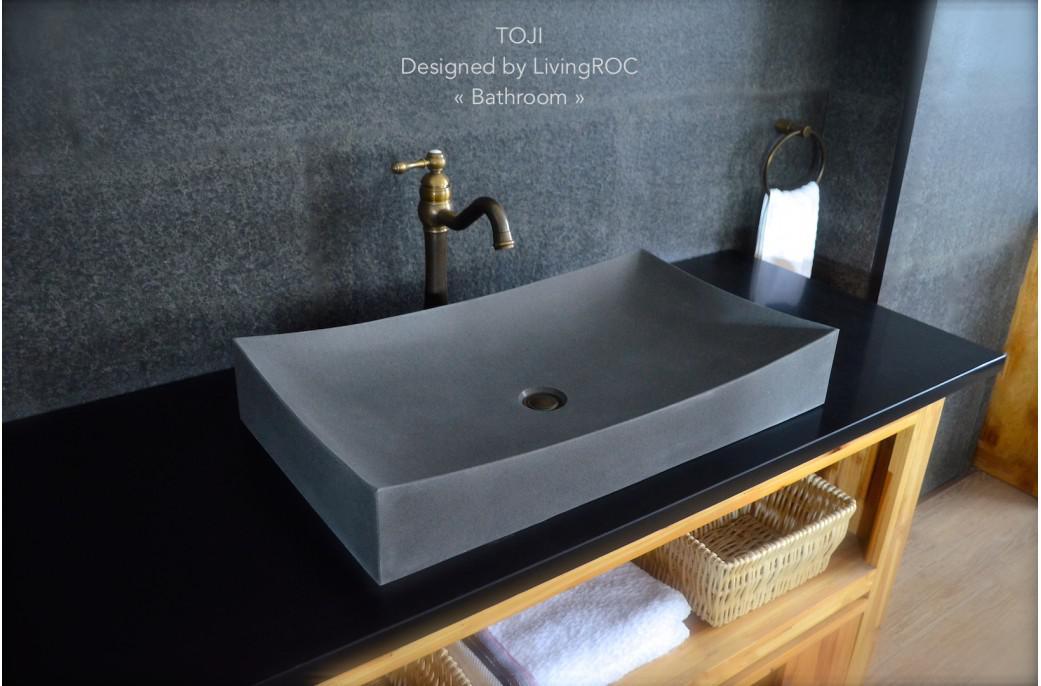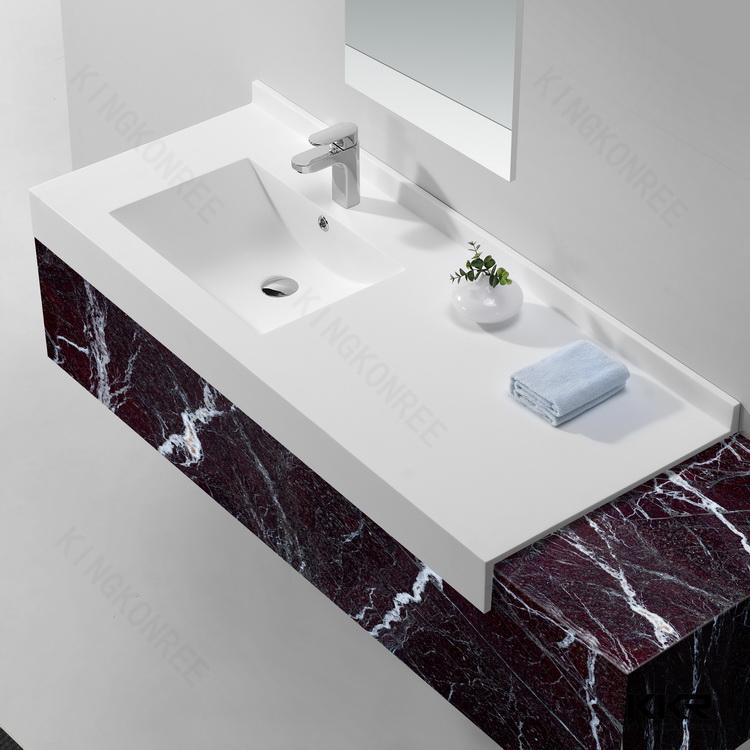The first image is the image on the left, the second image is the image on the right. For the images displayed, is the sentence "One image shows a rectangular vanity with a shell-shaped sink carved into it, beneath a fauced mounted on the wall." factually correct? Answer yes or no. No. 